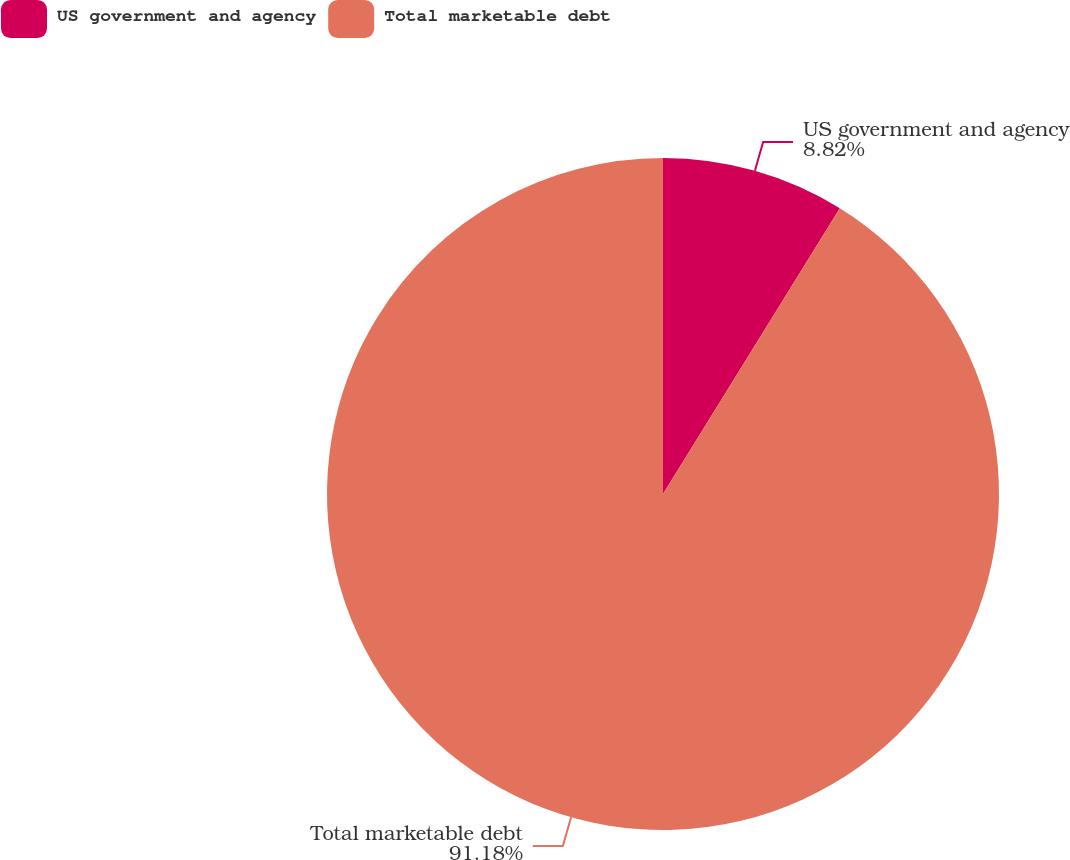<chart> <loc_0><loc_0><loc_500><loc_500><pie_chart><fcel>US government and agency<fcel>Total marketable debt<nl><fcel>8.82%<fcel>91.18%<nl></chart> 